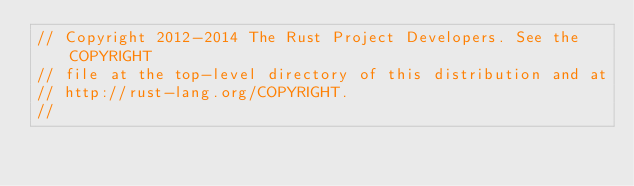Convert code to text. <code><loc_0><loc_0><loc_500><loc_500><_Rust_>// Copyright 2012-2014 The Rust Project Developers. See the COPYRIGHT
// file at the top-level directory of this distribution and at
// http://rust-lang.org/COPYRIGHT.
//</code> 